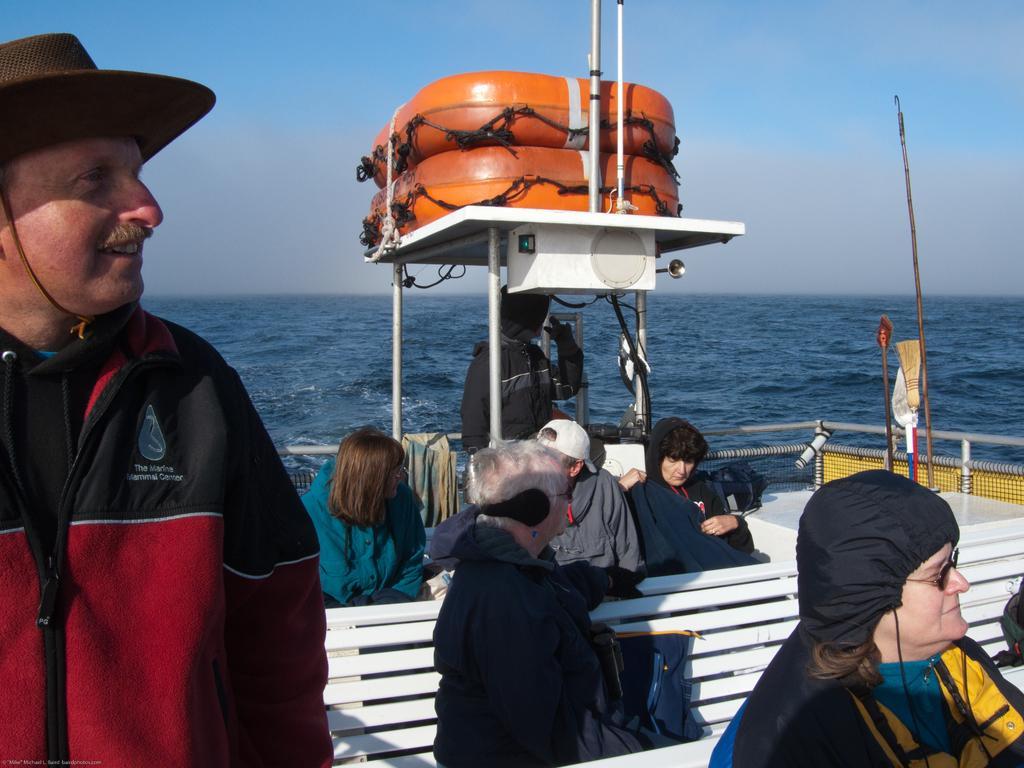How would you summarize this image in a sentence or two? In this image, we can see some water. There are a few people. We can see the table with some tubes and poles. We can see a bench. We can also see the fence and some cloth. We can also see objects and the sky. 